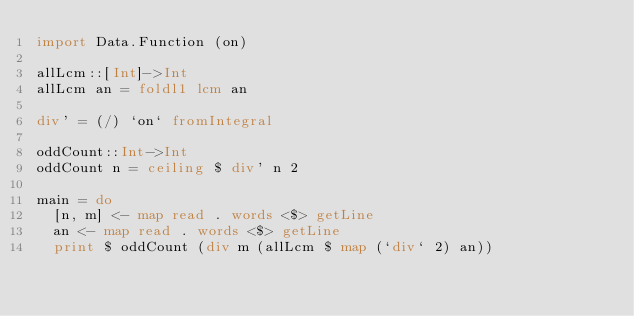<code> <loc_0><loc_0><loc_500><loc_500><_Haskell_>import Data.Function (on)

allLcm::[Int]->Int
allLcm an = foldl1 lcm an

div' = (/) `on` fromIntegral

oddCount::Int->Int
oddCount n = ceiling $ div' n 2

main = do
  [n, m] <- map read . words <$> getLine
  an <- map read . words <$> getLine
  print $ oddCount (div m (allLcm $ map (`div` 2) an))
</code> 